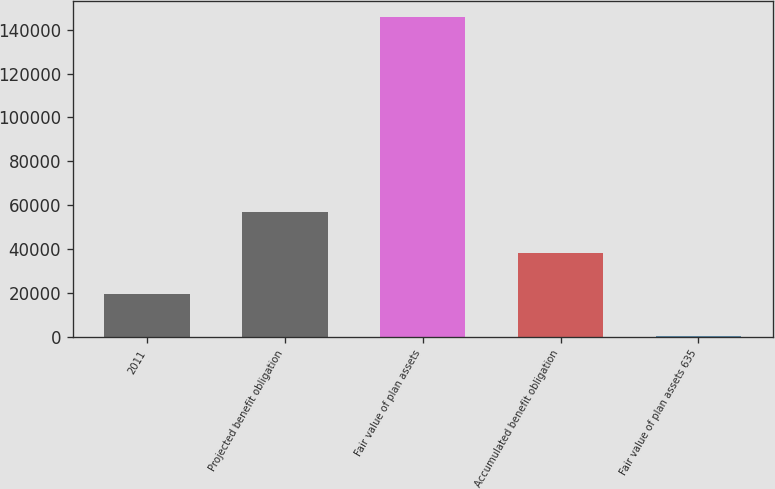Convert chart. <chart><loc_0><loc_0><loc_500><loc_500><bar_chart><fcel>2011<fcel>Projected benefit obligation<fcel>Fair value of plan assets<fcel>Accumulated benefit obligation<fcel>Fair value of plan assets 635<nl><fcel>19415.9<fcel>57043.7<fcel>145789<fcel>38229.8<fcel>602<nl></chart> 